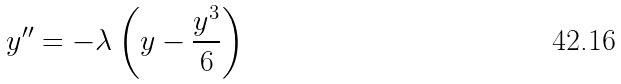Convert formula to latex. <formula><loc_0><loc_0><loc_500><loc_500>y ^ { \prime \prime } = - \lambda \left ( y - \frac { y ^ { 3 } } { 6 } \right )</formula> 